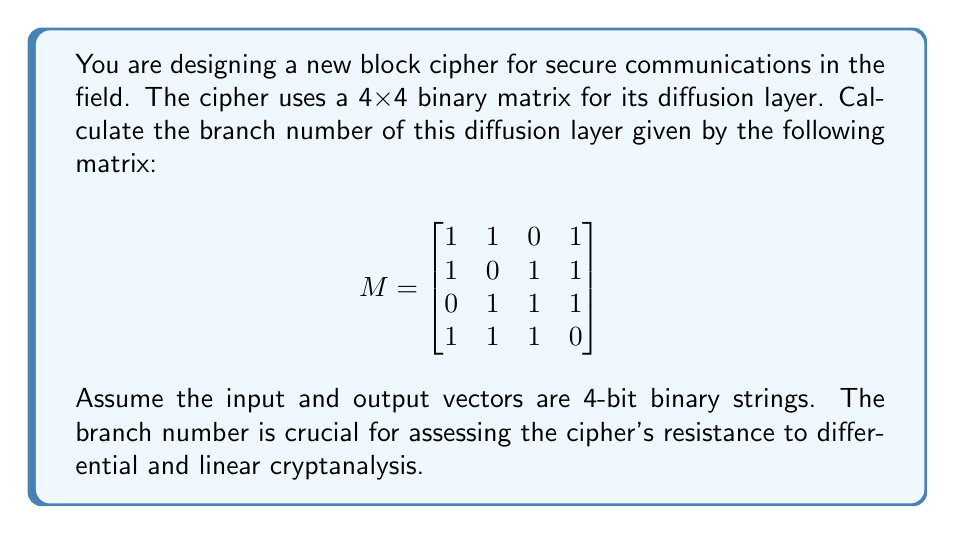Show me your answer to this math problem. To calculate the branch number of the diffusion layer, we need to follow these steps:

1) The branch number is defined as:
   $$B(M) = \min_{x \neq 0} (w(x) + w(M \cdot x))$$
   where $w(x)$ is the Hamming weight (number of non-zero elements) of $x$.

2) We need to consider all possible non-zero 4-bit input vectors $x$ and their corresponding outputs $M \cdot x$.

3) Let's calculate for a few examples:

   For $x = [1,0,0,0]$:
   $$M \cdot [1,0,0,0] = [1,1,0,1]$$
   $w(x) + w(M \cdot x) = 1 + 3 = 4$

   For $x = [1,1,0,0]$:
   $$M \cdot [1,1,0,0] = [2,1,1,2] \equiv [0,1,1,0] \pmod{2}$$
   $w(x) + w(M \cdot x) = 2 + 2 = 4$

4) After checking all possible non-zero inputs, we find that the minimum sum of input and output weights is 3.

5) Therefore, the branch number of this diffusion layer is 3.

This branch number indicates that changing one input bit will change at least two output bits (or vice versa), providing a moderate level of diffusion.
Answer: 3 